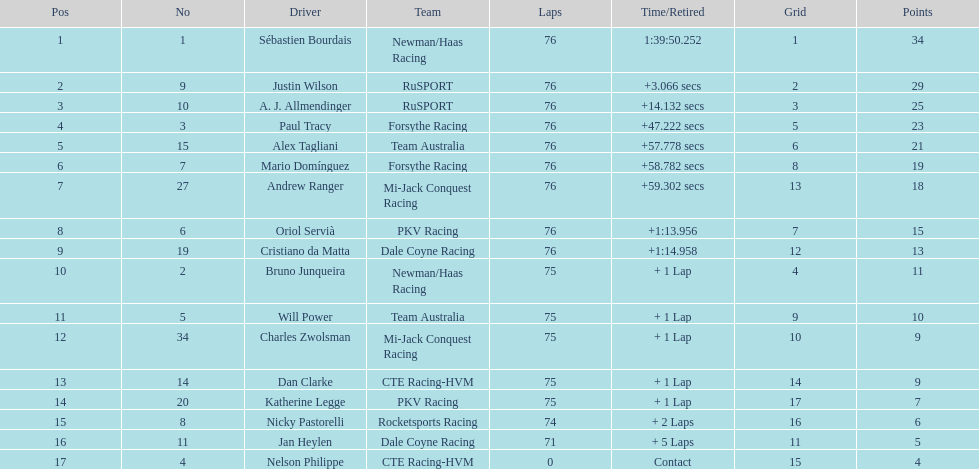Which driver has the least amount of points? Nelson Philippe. 